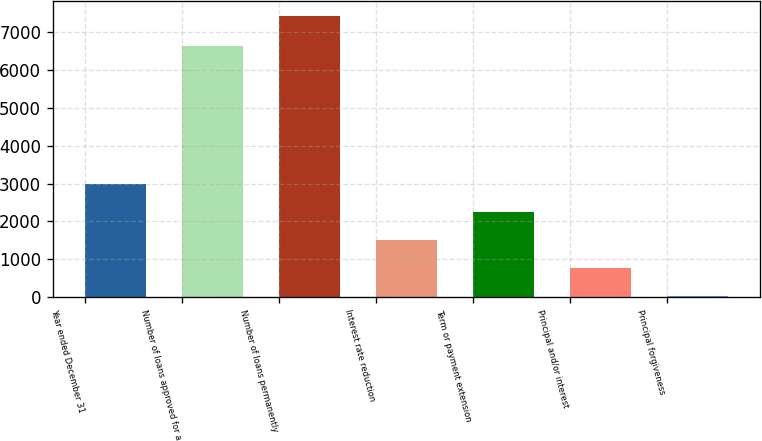Convert chart. <chart><loc_0><loc_0><loc_500><loc_500><bar_chart><fcel>Year ended December 31<fcel>Number of loans approved for a<fcel>Number of loans permanently<fcel>Interest rate reduction<fcel>Term or payment extension<fcel>Principal and/or interest<fcel>Principal forgiveness<nl><fcel>2986<fcel>6644<fcel>7441<fcel>1501<fcel>2243.5<fcel>758.5<fcel>16<nl></chart> 